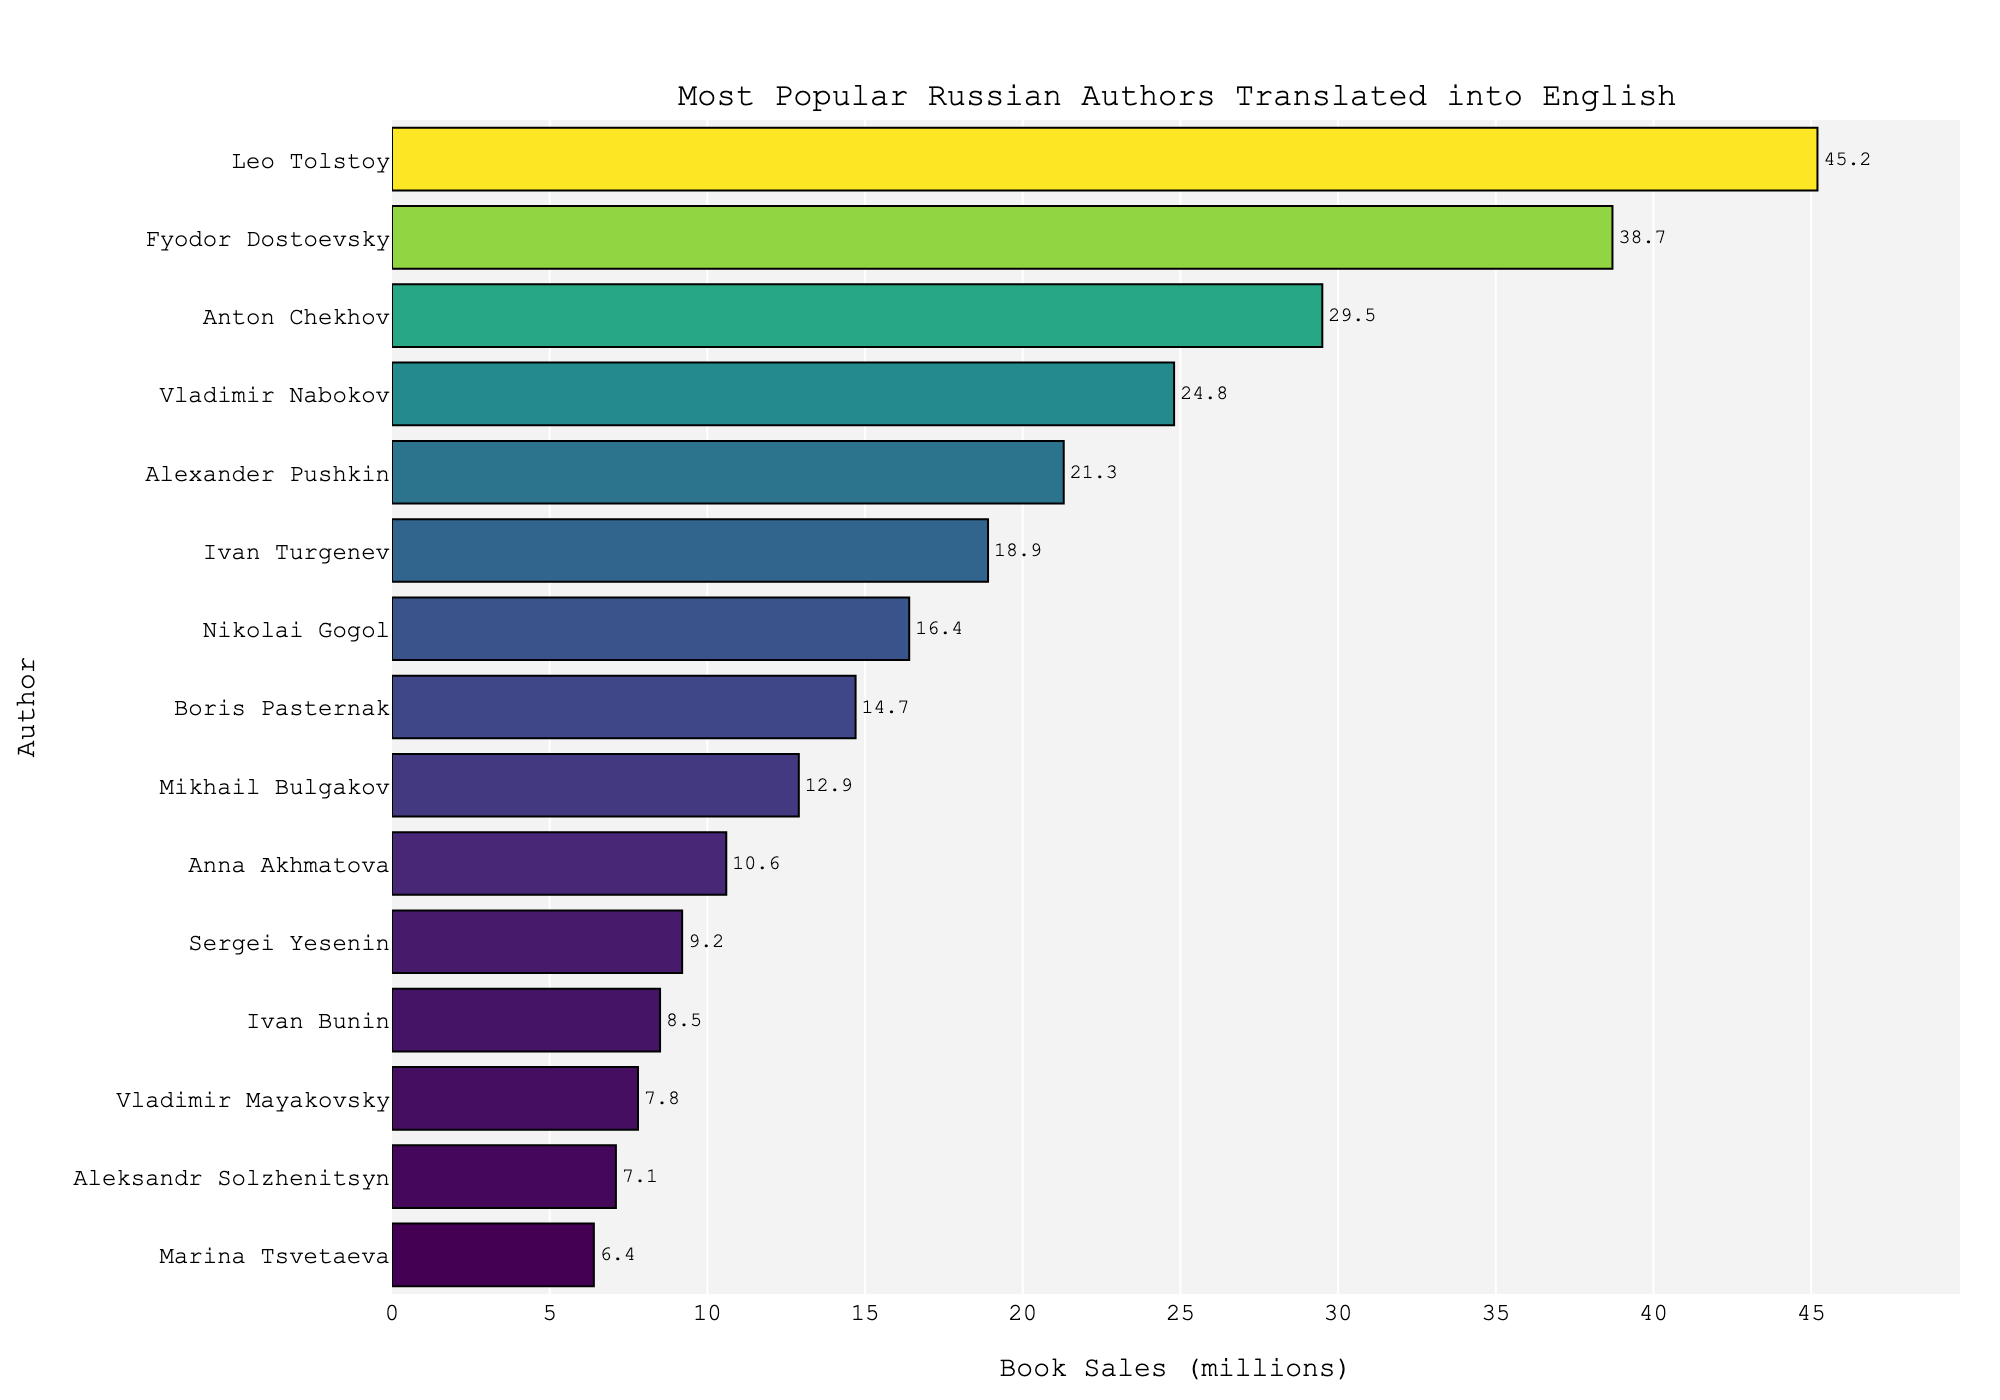Who is the top-selling Russian author translated into English? The bar with the highest book sales in millions represents the top-selling author.
Answer: Leo Tolstoy Which author has the second highest book sales? The second tallest bar in the chart represents the author with the second highest book sales.
Answer: Fyodor Dostoevsky What is the difference in book sales between Leo Tolstoy and Fyodor Dostoevsky? Subtract the book sales of Fyodor Dostoevsky from the book sales of Leo Tolstoy (45.2 - 38.7).
Answer: 6.5 million Which authors have book sales greater than 20 million but less than 30 million? Select the authors whose bars lie between the 20 million and 30 million marks on the x-axis.
Answer: Anton Chekhov, Vladimir Nabokov, Alexander Pushkin What is the total book sales of the bottom five authors in the chart? Sum the book sales of the bottom five authors (Sergei Yesenin, Ivan Bunin, Vladimir Mayakovsky, Aleksandr Solzhenitsyn, Marina Tsvetaeva).
Answer: 39 million Which author has book sales just under 15 million? Identify the bar that is just under the 15 million mark on the x-axis.
Answer: Boris Pasternak How many authors have book sales less than 10 million? Count the bars that fall before the 10 million mark on the x-axis.
Answer: 4 authors What is the average book sales of the top three authors? Sum the book sales of the top three authors (Leo Tolstoy, Fyodor Dostoevsky, Anton Chekhov) and divide by 3 ((45.2 + 38.7 + 29.5) / 3).
Answer: 37.8 million Compare the book sales of Vladimir Mayakovsky and Aleksandr Solzhenitsyn. Determine if Vladimir Mayakovsky's bar is higher, lower, or equal to Aleksandr Solzhenitsyn's bar by comparing their lengths.
Answer: Vladimir Mayakovsky's book sales are higher Which author has book sales closest to the median among the provided authors? Sort the book sales values, find the middle value.
Answer: Ivan Turgenev 